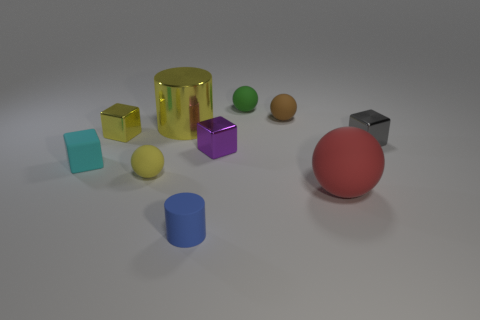How many small metal things have the same color as the big metal cylinder?
Provide a succinct answer. 1. Is the number of small shiny objects greater than the number of big red blocks?
Keep it short and to the point. Yes. How big is the object that is behind the big red thing and right of the small brown rubber thing?
Make the answer very short. Small. Is the small cube on the right side of the brown object made of the same material as the small ball that is in front of the brown thing?
Keep it short and to the point. No. What is the shape of the cyan thing that is the same size as the brown sphere?
Provide a succinct answer. Cube. Are there fewer cubes than small brown rubber balls?
Offer a very short reply. No. There is a large thing behind the tiny yellow matte sphere; is there a gray thing that is on the left side of it?
Ensure brevity in your answer.  No. Is there a green rubber thing left of the tiny yellow cube that is on the left side of the large thing on the left side of the blue cylinder?
Provide a short and direct response. No. There is a metallic thing on the right side of the tiny green sphere; does it have the same shape as the tiny yellow object in front of the small purple metallic thing?
Provide a succinct answer. No. There is a block that is made of the same material as the blue cylinder; what is its color?
Provide a short and direct response. Cyan. 